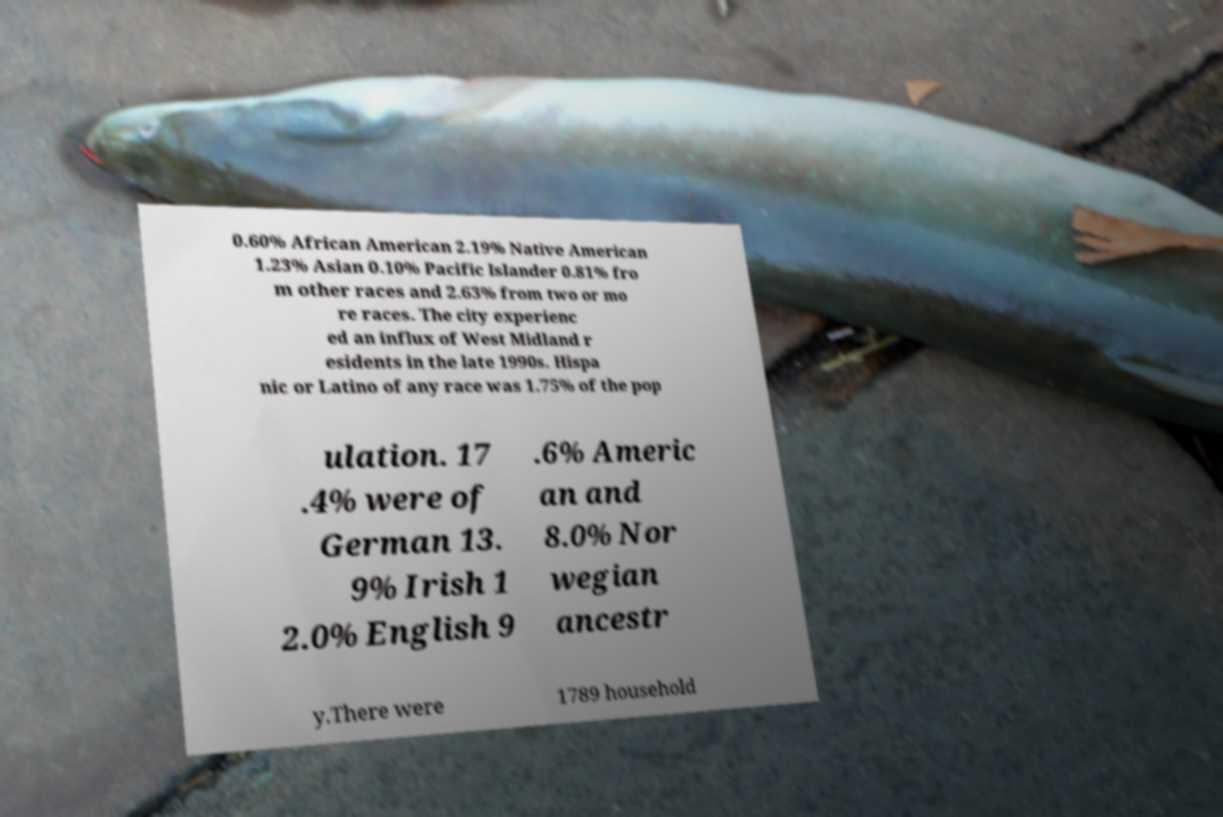What messages or text are displayed in this image? I need them in a readable, typed format. 0.60% African American 2.19% Native American 1.23% Asian 0.10% Pacific Islander 0.81% fro m other races and 2.63% from two or mo re races. The city experienc ed an influx of West Midland r esidents in the late 1990s. Hispa nic or Latino of any race was 1.75% of the pop ulation. 17 .4% were of German 13. 9% Irish 1 2.0% English 9 .6% Americ an and 8.0% Nor wegian ancestr y.There were 1789 household 